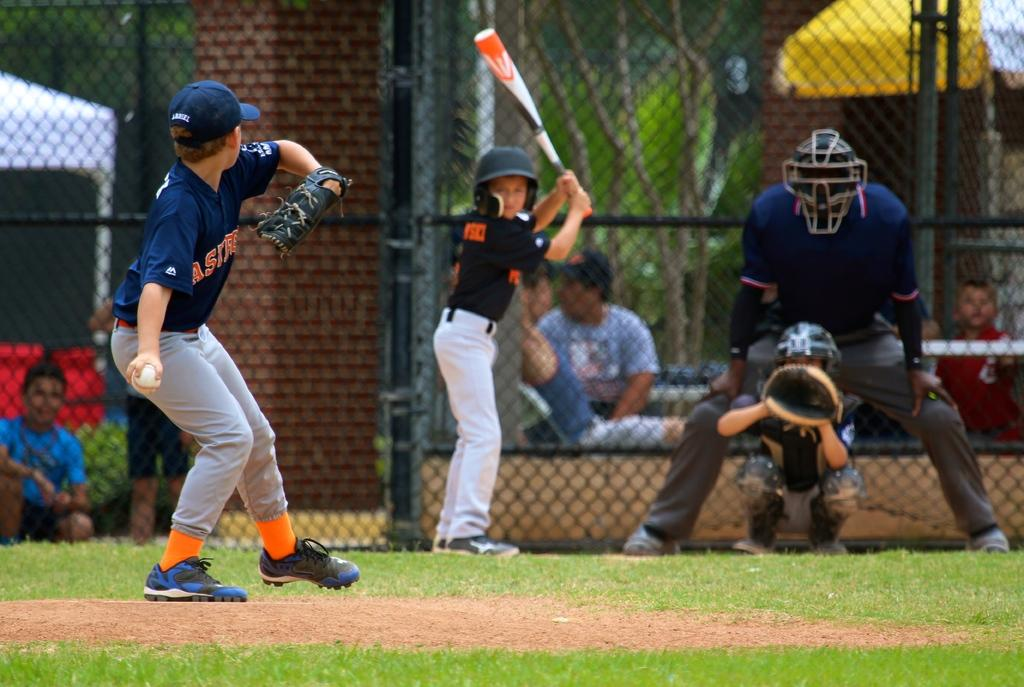<image>
Describe the image concisely. A boy is pitching a baseball and is part of a team whose name starts with A. 